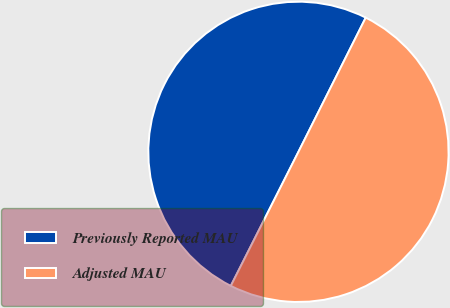Convert chart. <chart><loc_0><loc_0><loc_500><loc_500><pie_chart><fcel>Previously Reported MAU<fcel>Adjusted MAU<nl><fcel>49.96%<fcel>50.04%<nl></chart> 